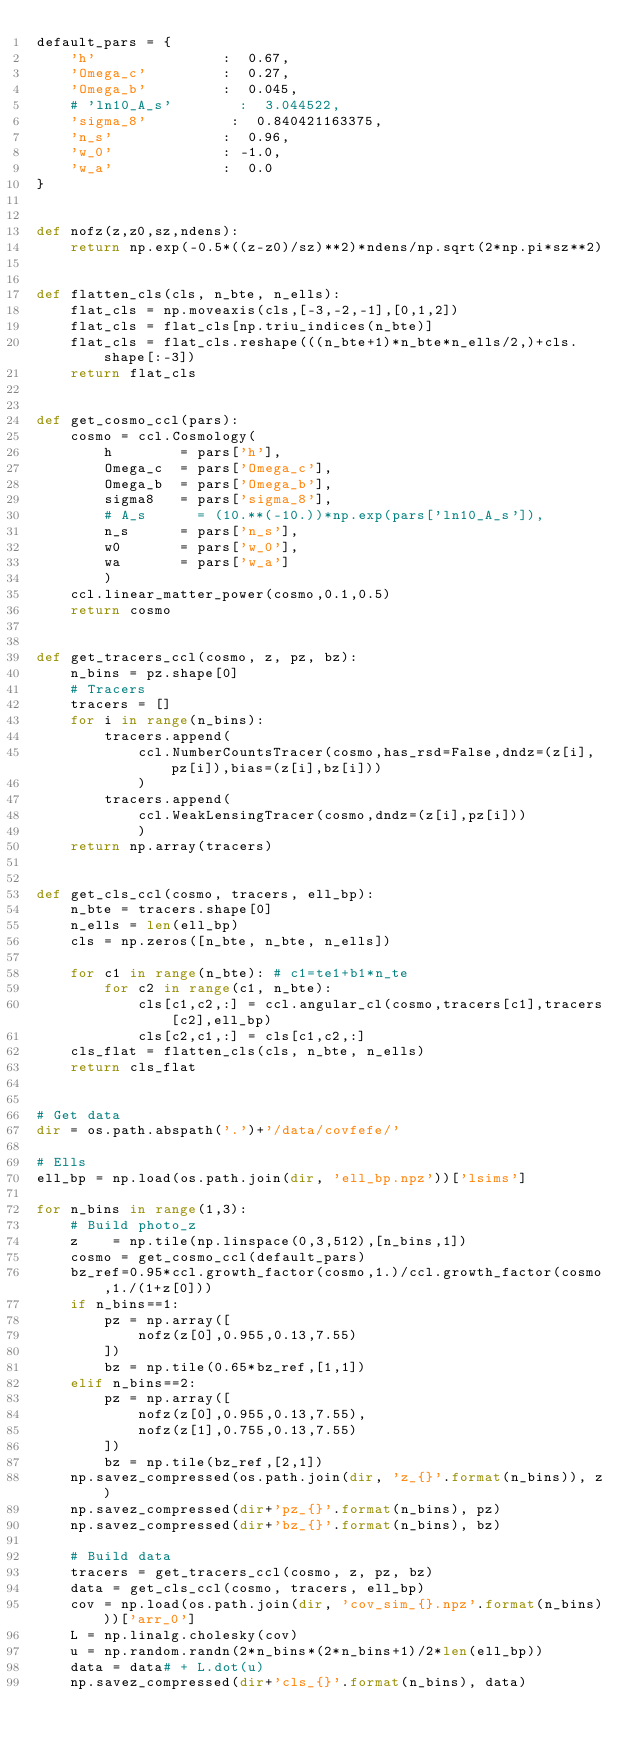Convert code to text. <code><loc_0><loc_0><loc_500><loc_500><_Python_>default_pars = {
    'h'               :  0.67,
    'Omega_c'         :  0.27,
    'Omega_b'         :  0.045,
    # 'ln10_A_s'        :  3.044522,
    'sigma_8'          :  0.840421163375,
    'n_s'             :  0.96,
    'w_0'             : -1.0,
    'w_a'             :  0.0
}


def nofz(z,z0,sz,ndens):
    return np.exp(-0.5*((z-z0)/sz)**2)*ndens/np.sqrt(2*np.pi*sz**2)


def flatten_cls(cls, n_bte, n_ells):
    flat_cls = np.moveaxis(cls,[-3,-2,-1],[0,1,2])
    flat_cls = flat_cls[np.triu_indices(n_bte)]
    flat_cls = flat_cls.reshape(((n_bte+1)*n_bte*n_ells/2,)+cls.shape[:-3])
    return flat_cls


def get_cosmo_ccl(pars):
    cosmo = ccl.Cosmology(
        h        = pars['h'],
        Omega_c  = pars['Omega_c'],
        Omega_b  = pars['Omega_b'],
        sigma8   = pars['sigma_8'],
        # A_s      = (10.**(-10.))*np.exp(pars['ln10_A_s']),
        n_s      = pars['n_s'],
        w0       = pars['w_0'],
        wa       = pars['w_a']
        )
    ccl.linear_matter_power(cosmo,0.1,0.5)
    return cosmo


def get_tracers_ccl(cosmo, z, pz, bz):
    n_bins = pz.shape[0]
    # Tracers
    tracers = []
    for i in range(n_bins):
        tracers.append(
            ccl.NumberCountsTracer(cosmo,has_rsd=False,dndz=(z[i],pz[i]),bias=(z[i],bz[i]))
            )
        tracers.append(
            ccl.WeakLensingTracer(cosmo,dndz=(z[i],pz[i]))
            )
    return np.array(tracers)


def get_cls_ccl(cosmo, tracers, ell_bp):
    n_bte = tracers.shape[0]
    n_ells = len(ell_bp)
    cls = np.zeros([n_bte, n_bte, n_ells])

    for c1 in range(n_bte): # c1=te1+b1*n_te
        for c2 in range(c1, n_bte):
            cls[c1,c2,:] = ccl.angular_cl(cosmo,tracers[c1],tracers[c2],ell_bp)
            cls[c2,c1,:] = cls[c1,c2,:]
    cls_flat = flatten_cls(cls, n_bte, n_ells)
    return cls_flat


# Get data
dir = os.path.abspath('.')+'/data/covfefe/'

# Ells
ell_bp = np.load(os.path.join(dir, 'ell_bp.npz'))['lsims']

for n_bins in range(1,3):
    # Build photo_z
    z    = np.tile(np.linspace(0,3,512),[n_bins,1])
    cosmo = get_cosmo_ccl(default_pars)
    bz_ref=0.95*ccl.growth_factor(cosmo,1.)/ccl.growth_factor(cosmo,1./(1+z[0]))
    if n_bins==1:
        pz = np.array([
            nofz(z[0],0.955,0.13,7.55)
        ])
        bz = np.tile(0.65*bz_ref,[1,1])
    elif n_bins==2:
        pz = np.array([
            nofz(z[0],0.955,0.13,7.55),
            nofz(z[1],0.755,0.13,7.55)
        ])
        bz = np.tile(bz_ref,[2,1])
    np.savez_compressed(os.path.join(dir, 'z_{}'.format(n_bins)), z)
    np.savez_compressed(dir+'pz_{}'.format(n_bins), pz)
    np.savez_compressed(dir+'bz_{}'.format(n_bins), bz)

    # Build data
    tracers = get_tracers_ccl(cosmo, z, pz, bz)
    data = get_cls_ccl(cosmo, tracers, ell_bp)
    cov = np.load(os.path.join(dir, 'cov_sim_{}.npz'.format(n_bins)))['arr_0']
    L = np.linalg.cholesky(cov)
    u = np.random.randn(2*n_bins*(2*n_bins+1)/2*len(ell_bp))
    data = data# + L.dot(u)
    np.savez_compressed(dir+'cls_{}'.format(n_bins), data)
</code> 